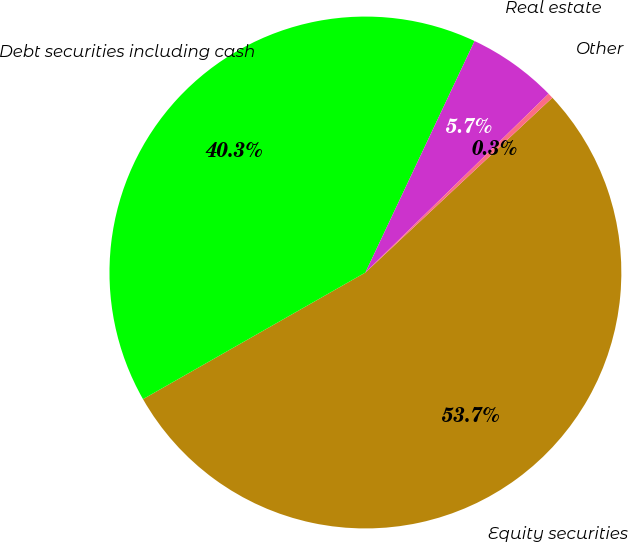<chart> <loc_0><loc_0><loc_500><loc_500><pie_chart><fcel>Equity securities<fcel>Debt securities including cash<fcel>Real estate<fcel>Other<nl><fcel>53.73%<fcel>40.25%<fcel>5.68%<fcel>0.34%<nl></chart> 